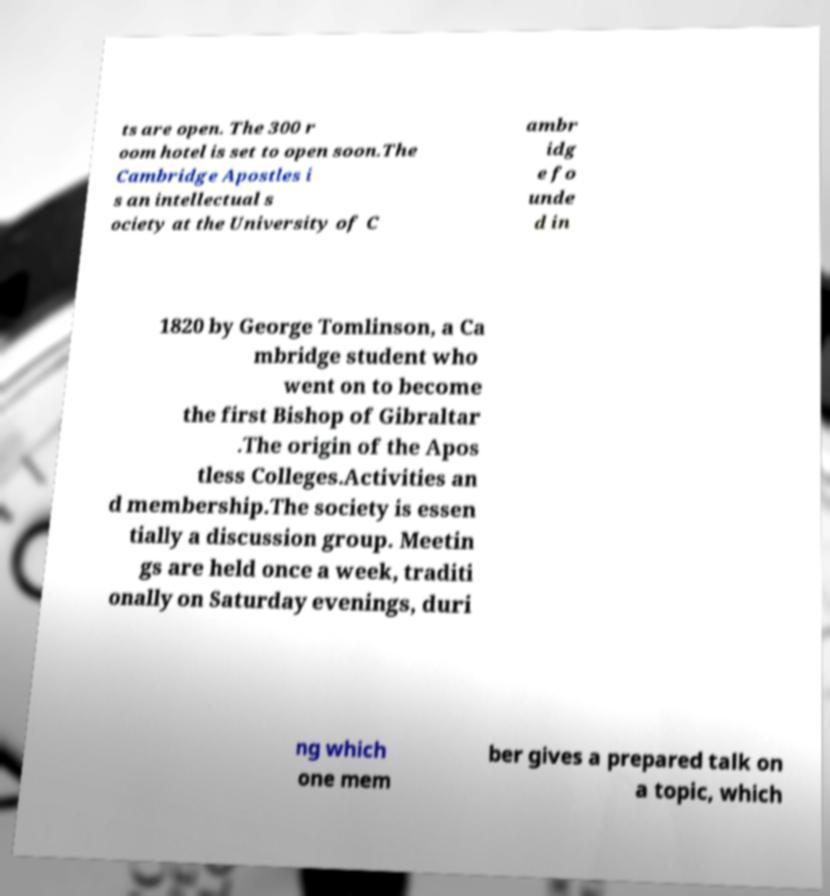Please read and relay the text visible in this image. What does it say? ts are open. The 300 r oom hotel is set to open soon.The Cambridge Apostles i s an intellectual s ociety at the University of C ambr idg e fo unde d in 1820 by George Tomlinson, a Ca mbridge student who went on to become the first Bishop of Gibraltar .The origin of the Apos tless Colleges.Activities an d membership.The society is essen tially a discussion group. Meetin gs are held once a week, traditi onally on Saturday evenings, duri ng which one mem ber gives a prepared talk on a topic, which 